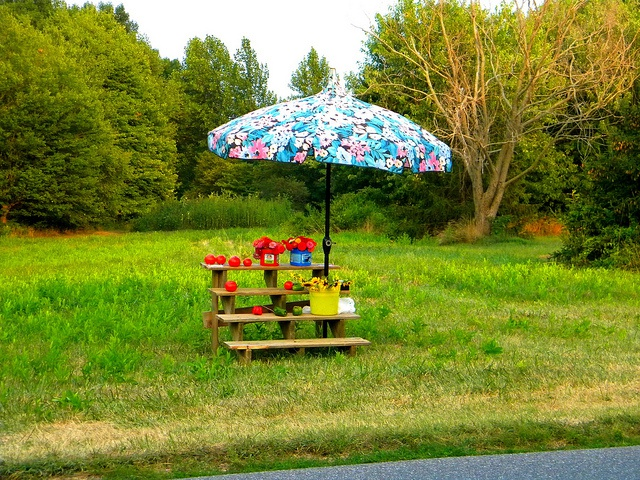Describe the objects in this image and their specific colors. I can see umbrella in darkgreen, white, lightblue, and darkgray tones, bench in darkgreen, olive, black, gold, and tan tones, bench in darkgreen, olive, black, tan, and khaki tones, potted plant in darkgreen, gold, and olive tones, and potted plant in darkgreen, red, brown, teal, and blue tones in this image. 